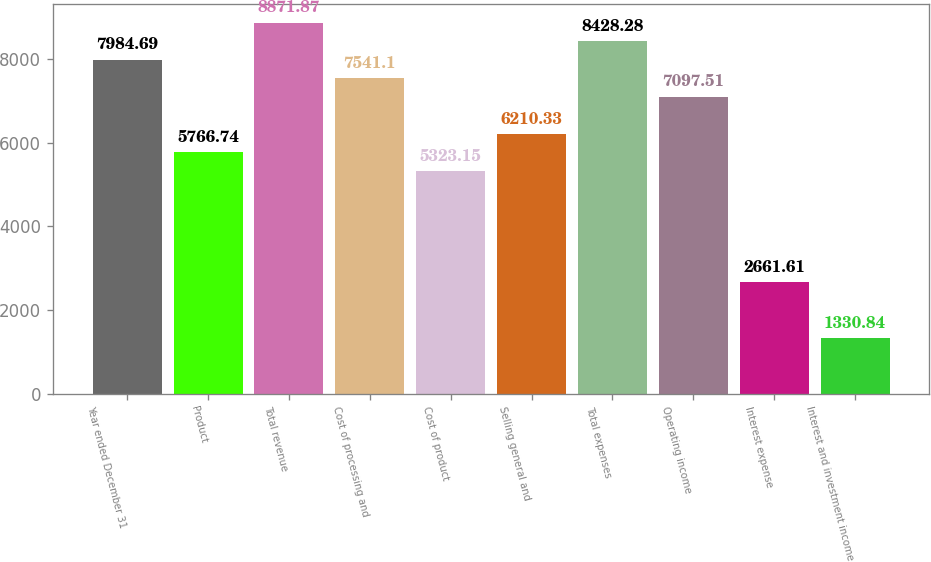<chart> <loc_0><loc_0><loc_500><loc_500><bar_chart><fcel>Year ended December 31<fcel>Product<fcel>Total revenue<fcel>Cost of processing and<fcel>Cost of product<fcel>Selling general and<fcel>Total expenses<fcel>Operating income<fcel>Interest expense<fcel>Interest and investment income<nl><fcel>7984.69<fcel>5766.74<fcel>8871.87<fcel>7541.1<fcel>5323.15<fcel>6210.33<fcel>8428.28<fcel>7097.51<fcel>2661.61<fcel>1330.84<nl></chart> 